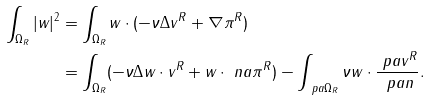Convert formula to latex. <formula><loc_0><loc_0><loc_500><loc_500>\int _ { \Omega _ { R } } | w | ^ { 2 } & = \int _ { \Omega _ { R } } w \cdot ( - \nu \Delta v ^ { R } + \nabla \pi ^ { R } ) \\ & = \int _ { \Omega _ { R } } ( - \nu \Delta w \cdot v ^ { R } + w \cdot \ n a \pi ^ { R } ) - \int _ { \ p a \Omega _ { R } } \nu w \cdot \frac { \ p a v ^ { R } } { \ p a n } .</formula> 